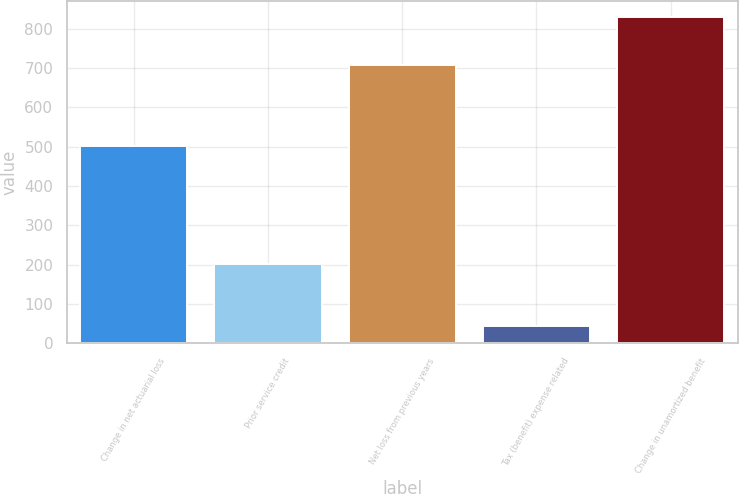Convert chart. <chart><loc_0><loc_0><loc_500><loc_500><bar_chart><fcel>Change in net actuarial loss<fcel>Prior service credit<fcel>Net loss from previous years<fcel>Tax (benefit) expense related<fcel>Change in unamortized benefit<nl><fcel>501<fcel>202<fcel>709<fcel>45<fcel>830<nl></chart> 